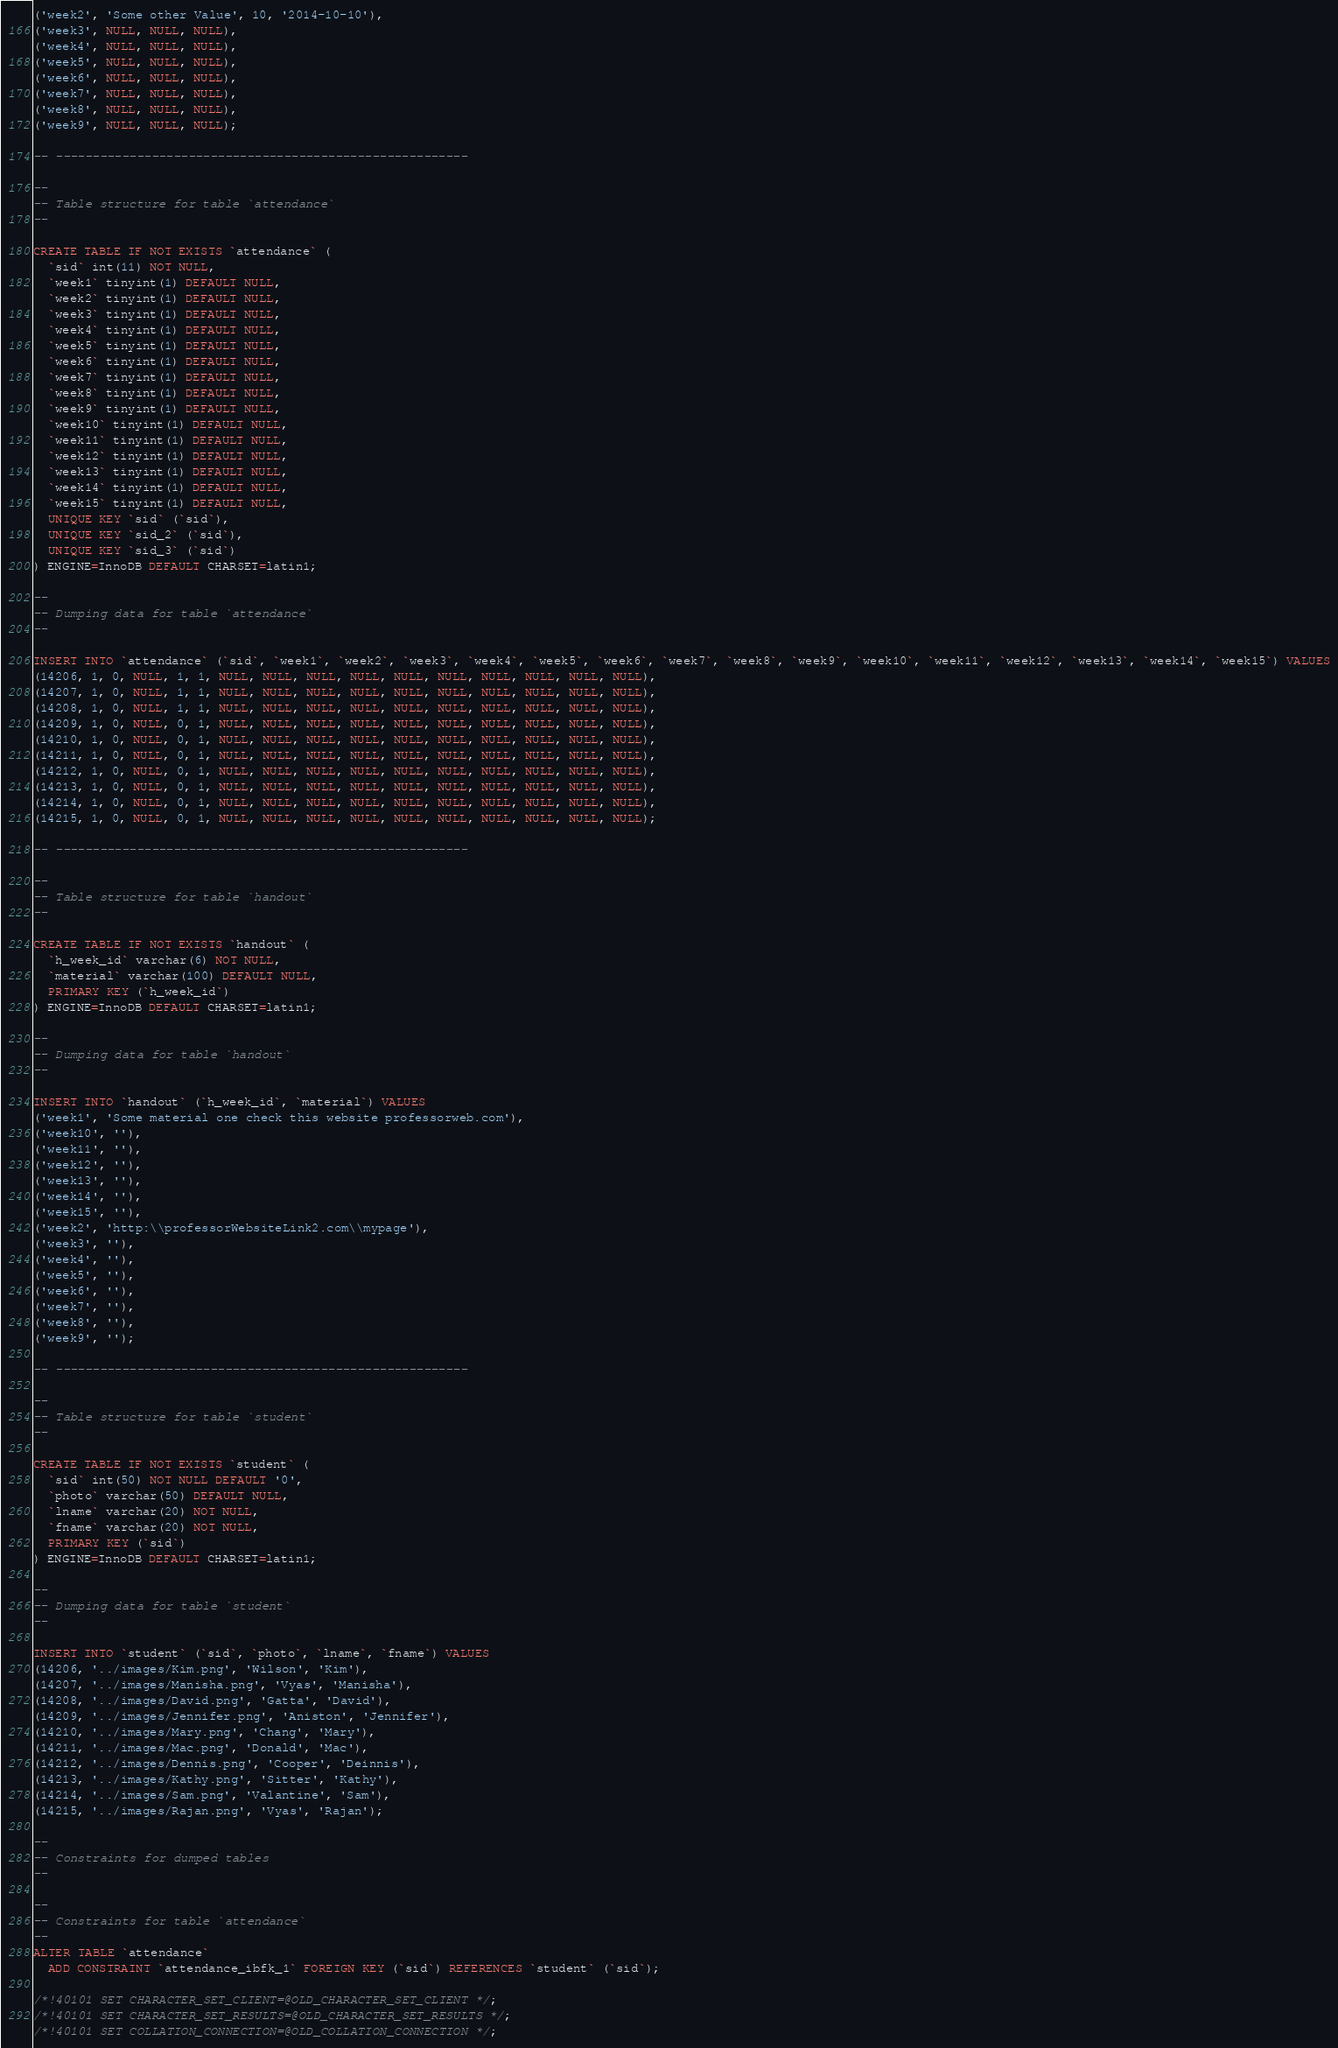<code> <loc_0><loc_0><loc_500><loc_500><_SQL_>('week2', 'Some other Value', 10, '2014-10-10'),
('week3', NULL, NULL, NULL),
('week4', NULL, NULL, NULL),
('week5', NULL, NULL, NULL),
('week6', NULL, NULL, NULL),
('week7', NULL, NULL, NULL),
('week8', NULL, NULL, NULL),
('week9', NULL, NULL, NULL);

-- --------------------------------------------------------

--
-- Table structure for table `attendance`
--

CREATE TABLE IF NOT EXISTS `attendance` (
  `sid` int(11) NOT NULL,
  `week1` tinyint(1) DEFAULT NULL,
  `week2` tinyint(1) DEFAULT NULL,
  `week3` tinyint(1) DEFAULT NULL,
  `week4` tinyint(1) DEFAULT NULL,
  `week5` tinyint(1) DEFAULT NULL,
  `week6` tinyint(1) DEFAULT NULL,
  `week7` tinyint(1) DEFAULT NULL,
  `week8` tinyint(1) DEFAULT NULL,
  `week9` tinyint(1) DEFAULT NULL,
  `week10` tinyint(1) DEFAULT NULL,
  `week11` tinyint(1) DEFAULT NULL,
  `week12` tinyint(1) DEFAULT NULL,
  `week13` tinyint(1) DEFAULT NULL,
  `week14` tinyint(1) DEFAULT NULL,
  `week15` tinyint(1) DEFAULT NULL,
  UNIQUE KEY `sid` (`sid`),
  UNIQUE KEY `sid_2` (`sid`),
  UNIQUE KEY `sid_3` (`sid`)
) ENGINE=InnoDB DEFAULT CHARSET=latin1;

--
-- Dumping data for table `attendance`
--

INSERT INTO `attendance` (`sid`, `week1`, `week2`, `week3`, `week4`, `week5`, `week6`, `week7`, `week8`, `week9`, `week10`, `week11`, `week12`, `week13`, `week14`, `week15`) VALUES
(14206, 1, 0, NULL, 1, 1, NULL, NULL, NULL, NULL, NULL, NULL, NULL, NULL, NULL, NULL),
(14207, 1, 0, NULL, 1, 1, NULL, NULL, NULL, NULL, NULL, NULL, NULL, NULL, NULL, NULL),
(14208, 1, 0, NULL, 1, 1, NULL, NULL, NULL, NULL, NULL, NULL, NULL, NULL, NULL, NULL),
(14209, 1, 0, NULL, 0, 1, NULL, NULL, NULL, NULL, NULL, NULL, NULL, NULL, NULL, NULL),
(14210, 1, 0, NULL, 0, 1, NULL, NULL, NULL, NULL, NULL, NULL, NULL, NULL, NULL, NULL),
(14211, 1, 0, NULL, 0, 1, NULL, NULL, NULL, NULL, NULL, NULL, NULL, NULL, NULL, NULL),
(14212, 1, 0, NULL, 0, 1, NULL, NULL, NULL, NULL, NULL, NULL, NULL, NULL, NULL, NULL),
(14213, 1, 0, NULL, 0, 1, NULL, NULL, NULL, NULL, NULL, NULL, NULL, NULL, NULL, NULL),
(14214, 1, 0, NULL, 0, 1, NULL, NULL, NULL, NULL, NULL, NULL, NULL, NULL, NULL, NULL),
(14215, 1, 0, NULL, 0, 1, NULL, NULL, NULL, NULL, NULL, NULL, NULL, NULL, NULL, NULL);

-- --------------------------------------------------------

--
-- Table structure for table `handout`
--

CREATE TABLE IF NOT EXISTS `handout` (
  `h_week_id` varchar(6) NOT NULL,
  `material` varchar(100) DEFAULT NULL,
  PRIMARY KEY (`h_week_id`)
) ENGINE=InnoDB DEFAULT CHARSET=latin1;

--
-- Dumping data for table `handout`
--

INSERT INTO `handout` (`h_week_id`, `material`) VALUES
('week1', 'Some material one check this website professorweb.com'),
('week10', ''),
('week11', ''),
('week12', ''),
('week13', ''),
('week14', ''),
('week15', ''),
('week2', 'http:\\professorWebsiteLink2.com\\mypage'),
('week3', ''),
('week4', ''),
('week5', ''),
('week6', ''),
('week7', ''),
('week8', ''),
('week9', '');

-- --------------------------------------------------------

--
-- Table structure for table `student`
--

CREATE TABLE IF NOT EXISTS `student` (
  `sid` int(50) NOT NULL DEFAULT '0',
  `photo` varchar(50) DEFAULT NULL,
  `lname` varchar(20) NOT NULL,
  `fname` varchar(20) NOT NULL,
  PRIMARY KEY (`sid`)
) ENGINE=InnoDB DEFAULT CHARSET=latin1;

--
-- Dumping data for table `student`
--

INSERT INTO `student` (`sid`, `photo`, `lname`, `fname`) VALUES
(14206, '../images/Kim.png', 'Wilson', 'Kim'),
(14207, '../images/Manisha.png', 'Vyas', 'Manisha'),
(14208, '../images/David.png', 'Gatta', 'David'),
(14209, '../images/Jennifer.png', 'Aniston', 'Jennifer'),
(14210, '../images/Mary.png', 'Chang', 'Mary'),
(14211, '../images/Mac.png', 'Donald', 'Mac'),
(14212, '../images/Dennis.png', 'Cooper', 'Deinnis'),
(14213, '../images/Kathy.png', 'Sitter', 'Kathy'),
(14214, '../images/Sam.png', 'Valantine', 'Sam'),
(14215, '../images/Rajan.png', 'Vyas', 'Rajan');

--
-- Constraints for dumped tables
--

--
-- Constraints for table `attendance`
--
ALTER TABLE `attendance`
  ADD CONSTRAINT `attendance_ibfk_1` FOREIGN KEY (`sid`) REFERENCES `student` (`sid`);

/*!40101 SET CHARACTER_SET_CLIENT=@OLD_CHARACTER_SET_CLIENT */;
/*!40101 SET CHARACTER_SET_RESULTS=@OLD_CHARACTER_SET_RESULTS */;
/*!40101 SET COLLATION_CONNECTION=@OLD_COLLATION_CONNECTION */;
</code> 